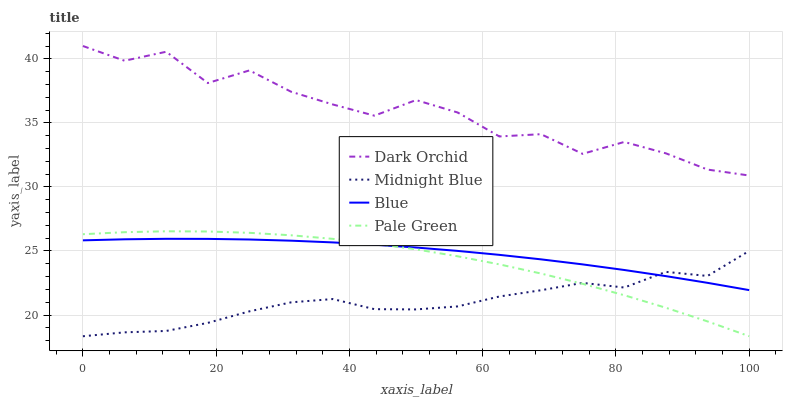Does Midnight Blue have the minimum area under the curve?
Answer yes or no. Yes. Does Dark Orchid have the maximum area under the curve?
Answer yes or no. Yes. Does Pale Green have the minimum area under the curve?
Answer yes or no. No. Does Pale Green have the maximum area under the curve?
Answer yes or no. No. Is Blue the smoothest?
Answer yes or no. Yes. Is Dark Orchid the roughest?
Answer yes or no. Yes. Is Pale Green the smoothest?
Answer yes or no. No. Is Pale Green the roughest?
Answer yes or no. No. Does Midnight Blue have the lowest value?
Answer yes or no. Yes. Does Pale Green have the lowest value?
Answer yes or no. No. Does Dark Orchid have the highest value?
Answer yes or no. Yes. Does Pale Green have the highest value?
Answer yes or no. No. Is Blue less than Dark Orchid?
Answer yes or no. Yes. Is Dark Orchid greater than Blue?
Answer yes or no. Yes. Does Blue intersect Pale Green?
Answer yes or no. Yes. Is Blue less than Pale Green?
Answer yes or no. No. Is Blue greater than Pale Green?
Answer yes or no. No. Does Blue intersect Dark Orchid?
Answer yes or no. No. 